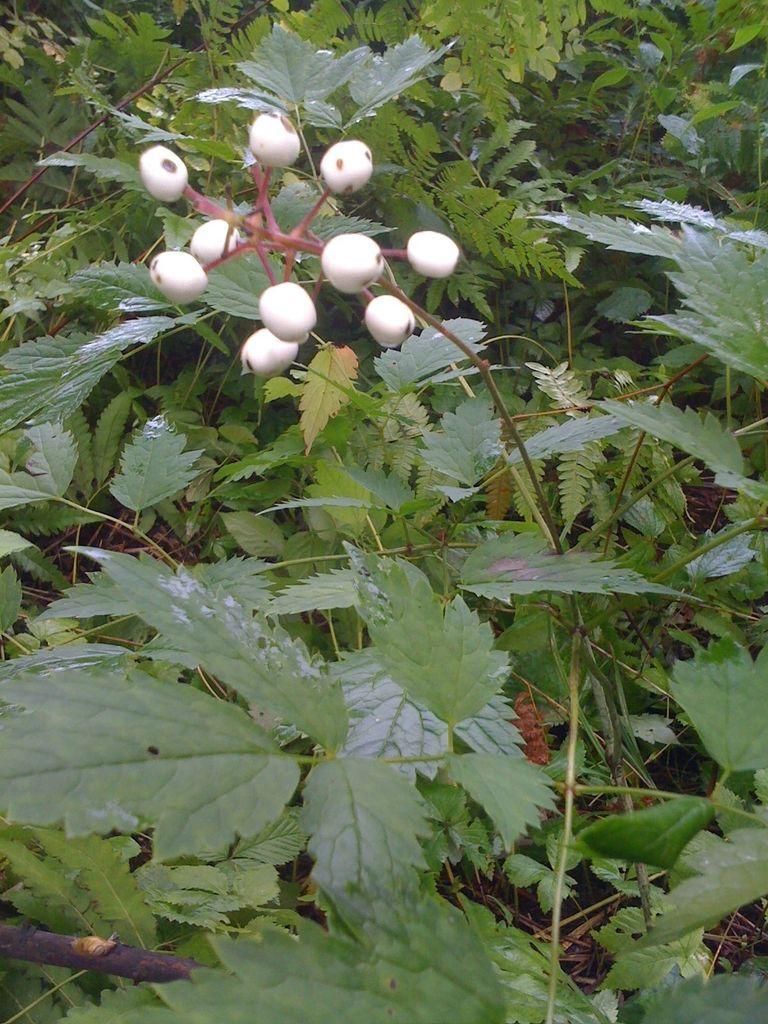How would you summarize this image in a sentence or two? In this image I can see number of green colour leaves and few white colour things on the top side of the image. 